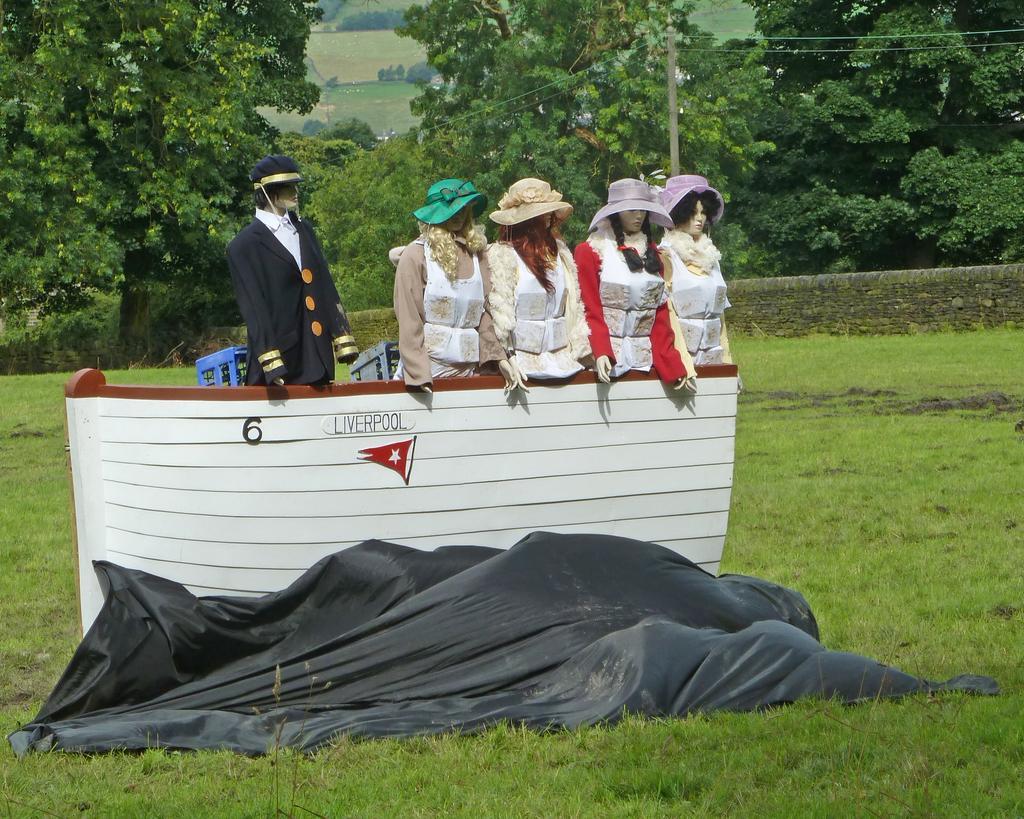How would you summarize this image in a sentence or two? In the center of the image we can see mannequins with costumes. At the bottom there is a board and a cover. In the background there are trees, pole and wires. At the bottom there is grass. 